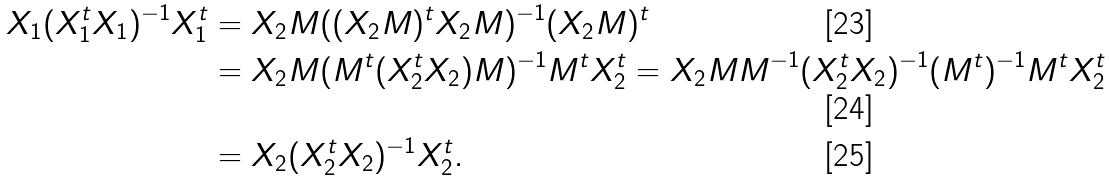<formula> <loc_0><loc_0><loc_500><loc_500>X _ { 1 } ( X _ { 1 } ^ { t } X _ { 1 } ) ^ { - 1 } X _ { 1 } ^ { t } & = X _ { 2 } M ( ( X _ { 2 } M ) ^ { t } X _ { 2 } M ) ^ { - 1 } ( X _ { 2 } M ) ^ { t } \\ & = X _ { 2 } M ( M ^ { t } ( X _ { 2 } ^ { t } X _ { 2 } ) M ) ^ { - 1 } M ^ { t } X _ { 2 } ^ { t } = X _ { 2 } M M ^ { - 1 } ( X _ { 2 } ^ { t } X _ { 2 } ) ^ { - 1 } ( M ^ { t } ) ^ { - 1 } M ^ { t } X _ { 2 } ^ { t } \\ & = X _ { 2 } ( X _ { 2 } ^ { t } X _ { 2 } ) ^ { - 1 } X _ { 2 } ^ { t } .</formula> 